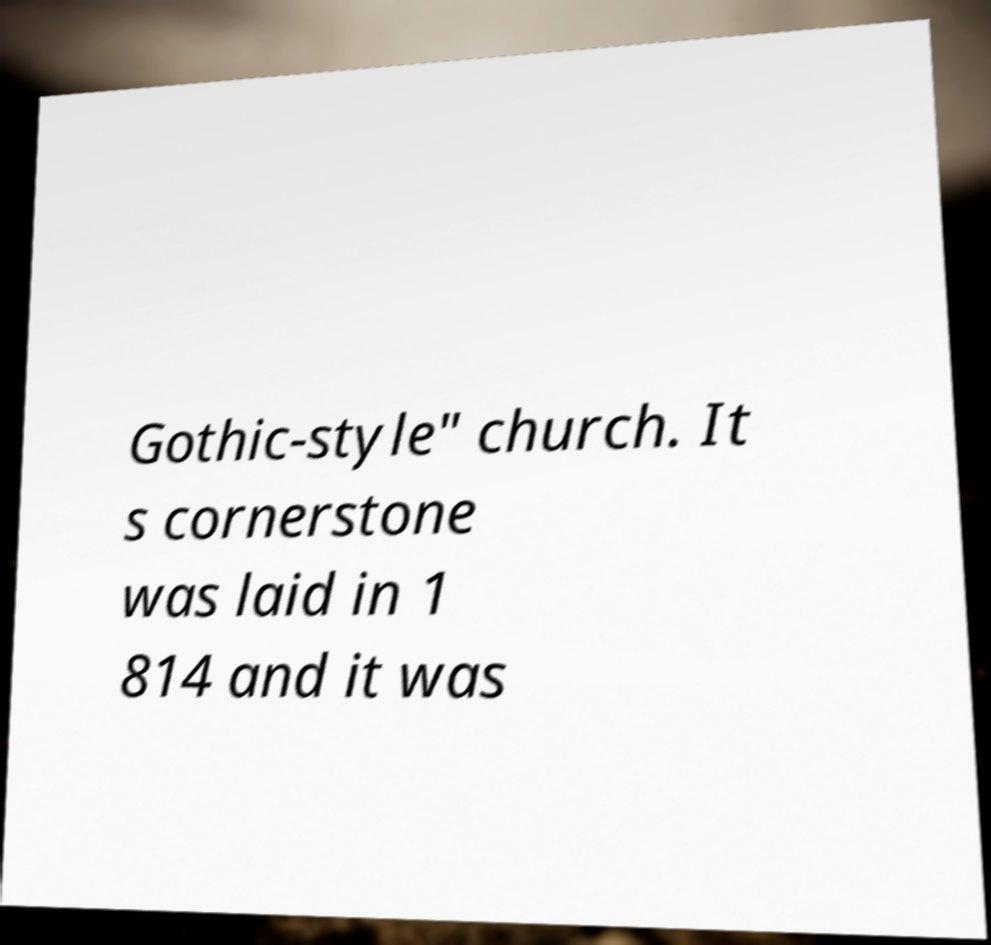Please identify and transcribe the text found in this image. Gothic-style" church. It s cornerstone was laid in 1 814 and it was 